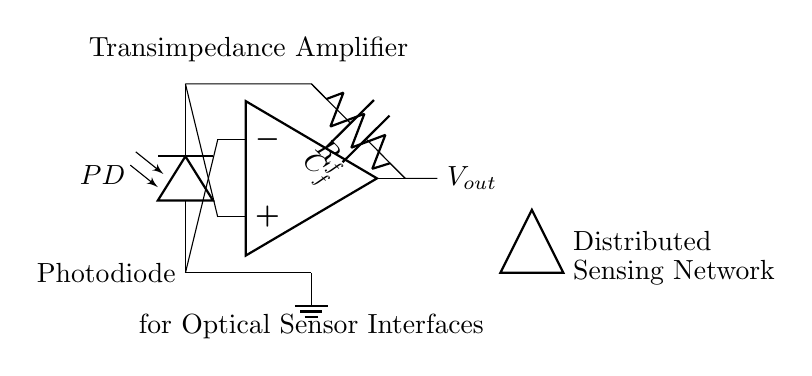What component is used to convert light into current? The photodiode is the component that converts incident light into a proportional electrical current. The diagram clearly labels this component as the "Photodiode."
Answer: Photodiode What is the purpose of the feedback resistor? The feedback resistor, labeled "R_f," is used to set the gain of the transimpedance amplifier by converting the photocurrent from the photodiode into a voltage output. Its value affects the output voltage corresponding to the input current.
Answer: Gain setting What is the function of the capacitor in this circuit? The capacitor, labeled "C_f," provides stability and bandwidth control in the transimpedance amplifier. It helps filter out high-frequency noise and ensures a stable output voltage by compensating for variations in the input signal.
Answer: Stability and filtering What is the output voltage connected to? The output voltage, labeled "V_out," is represented as the point where the output from the op-amp is directed to an external circuit or subsequent processing stage, indicating it's not connected directly to any other components in the diagram.
Answer: External circuit Why does the output depend on the photodiode current? The output of the transimpedance amplifier is directly proportional to the current generated by the photodiode, following Ohm's law and the design of the amplifier. Since the amplifier is in transimpedance configuration, it converts this current into a corresponding voltage, making it responsive to the light intensity detected by the photodiode.
Answer: Output proportional to photodiode current Which type of amplifier configuration is used in this circuit? The circuit is configured as a transimpedance amplifier, where the current from the photodiode is converted to voltage through feedback components, specifically the resistor and capacitor. This type is specific for applications where current must be translated to a usable voltage output.
Answer: Transimpedance amplifier 